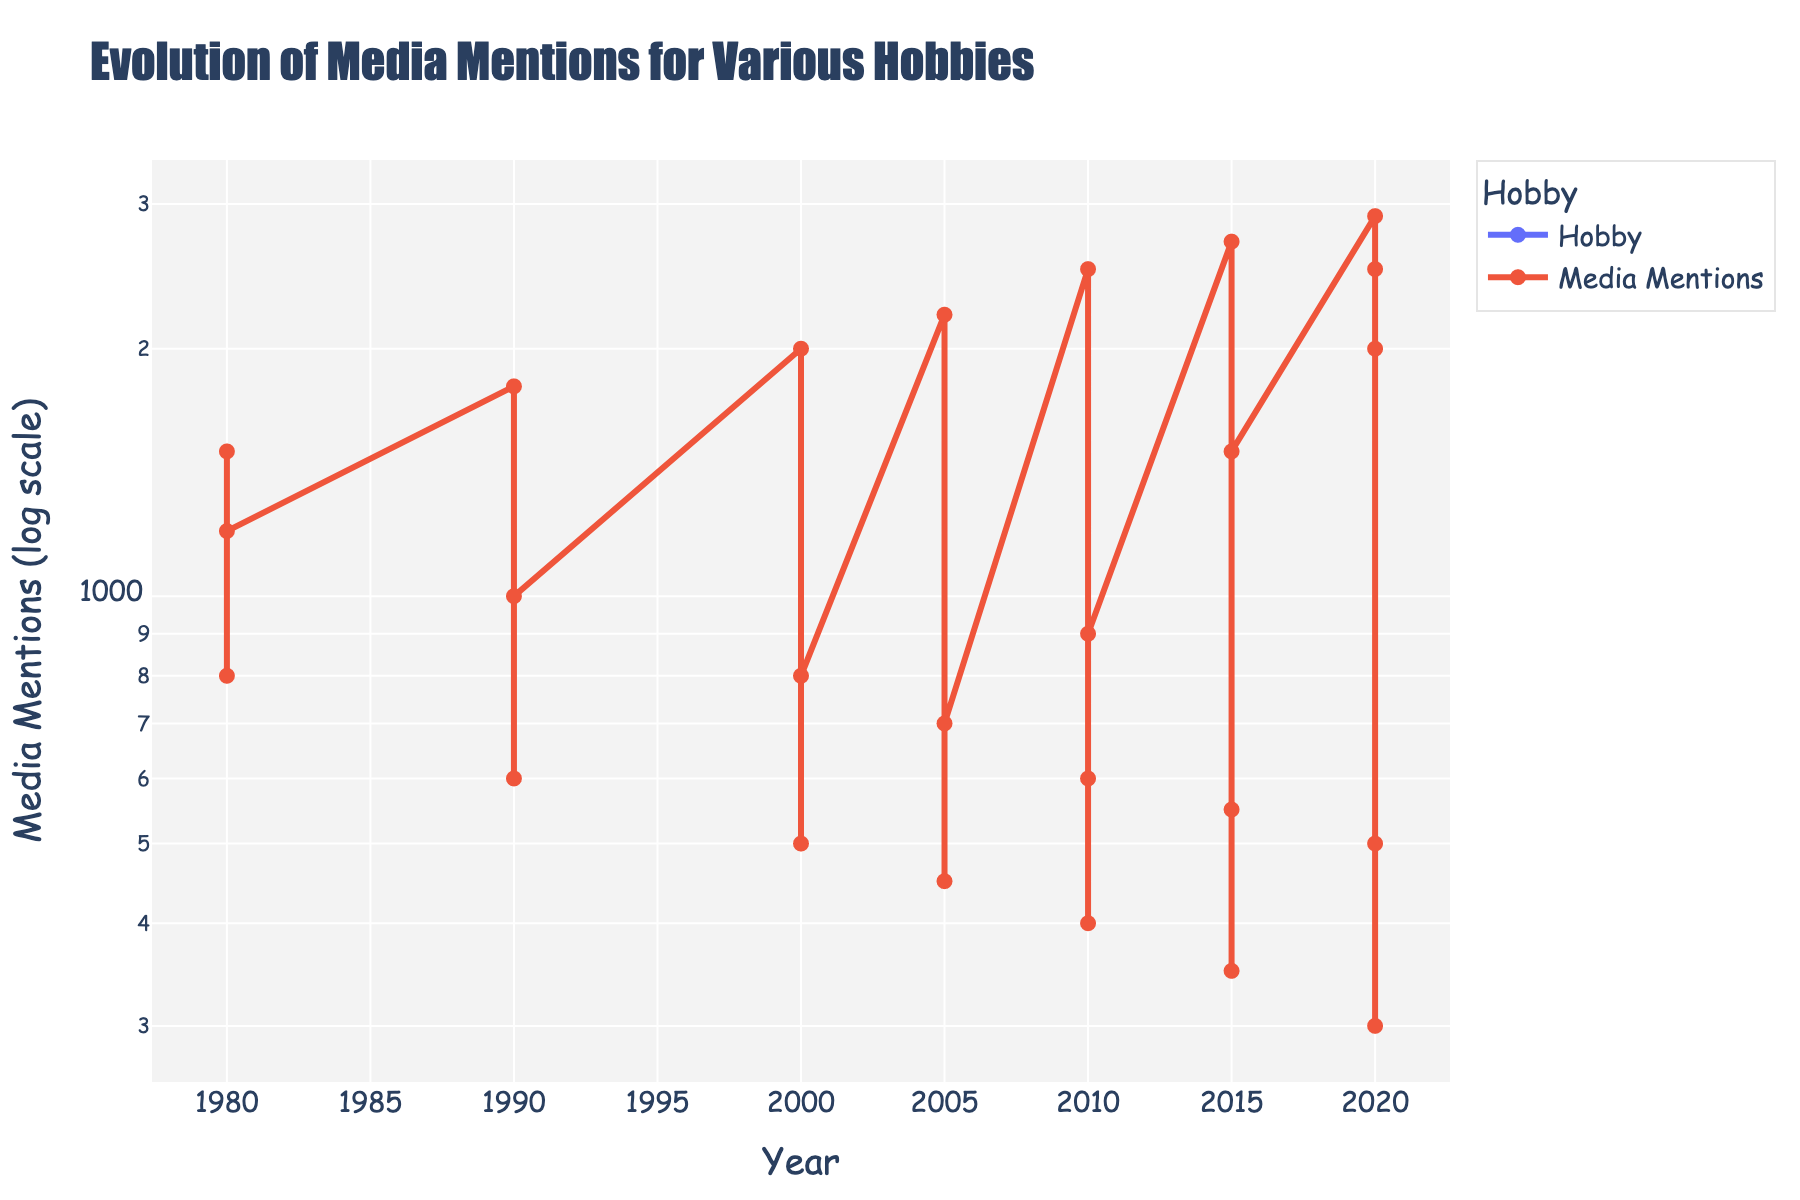What is the title of the figure? The title is shown at the top of the figure and provides a summary of what the figure represents.
Answer: Evolution of Media Mentions for Various Hobbies How many hobbies are shown in the year 2020? Check the data points for the year 2020 and count the distinct hobbies.
Answer: 5 Which hobby had the highest media mentions in 2010? Look at the data points for 2010 and identify the hobby with the highest value on the vertical axis.
Answer: Karate What trend can be observed for KiteFlying from 1980 to 2020? Observe the KiteFlying line from 1980 to 2020 and describe its general direction and pattern.
Answer: Decreasing What's the difference in media mentions for Karate between 1980 and 2020? Find the media mentions for Karate in 1980 (1500) and in 2020 (2900), then subtract the smaller value from the larger value.
Answer: 1400 Which hobby surpassed StampCollecting in media mentions between 2010 and 2015? Compare the media mentions of StampCollecting and VideoGaming in 2015.
Answer: VideoGaming What is the average media mention value for StampCollecting from 1980 to 2020? Sum the media mention values for StampCollecting from 1980 to 2020 (1200 + 1000 + 800 + 700 + 600 + 550 + 500) and divide by the number of data points (7).
Answer: 764 Which hobby shows a clear upward trend over the decades? Observe the lines and see which hobby consistently increases its media mentions over time.
Answer: Karate, VideoGaming, Esports Which year shows the largest increase in media mentions for VideoGaming? Compare the media mentions for VideoGaming in each year and find the biggest difference between consecutive years.
Answer: 2010 to 2015, increase of 600 How many data points are plotted in total? Count the total number of data points visible in the figure.
Answer: 21 